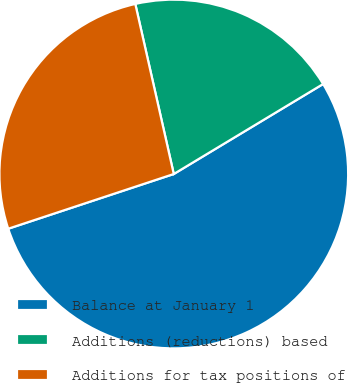<chart> <loc_0><loc_0><loc_500><loc_500><pie_chart><fcel>Balance at January 1<fcel>Additions (reductions) based<fcel>Additions for tax positions of<nl><fcel>53.55%<fcel>19.91%<fcel>26.54%<nl></chart> 